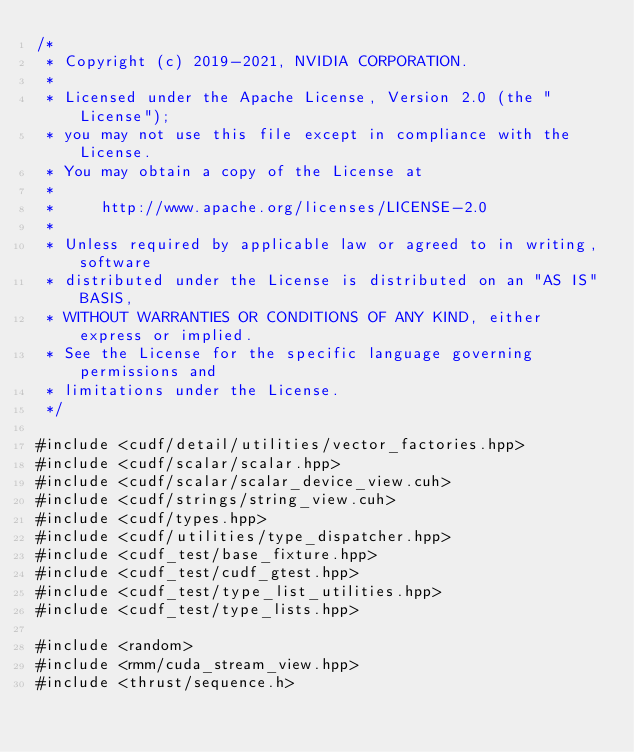<code> <loc_0><loc_0><loc_500><loc_500><_Cuda_>/*
 * Copyright (c) 2019-2021, NVIDIA CORPORATION.
 *
 * Licensed under the Apache License, Version 2.0 (the "License");
 * you may not use this file except in compliance with the License.
 * You may obtain a copy of the License at
 *
 *     http://www.apache.org/licenses/LICENSE-2.0
 *
 * Unless required by applicable law or agreed to in writing, software
 * distributed under the License is distributed on an "AS IS" BASIS,
 * WITHOUT WARRANTIES OR CONDITIONS OF ANY KIND, either express or implied.
 * See the License for the specific language governing permissions and
 * limitations under the License.
 */

#include <cudf/detail/utilities/vector_factories.hpp>
#include <cudf/scalar/scalar.hpp>
#include <cudf/scalar/scalar_device_view.cuh>
#include <cudf/strings/string_view.cuh>
#include <cudf/types.hpp>
#include <cudf/utilities/type_dispatcher.hpp>
#include <cudf_test/base_fixture.hpp>
#include <cudf_test/cudf_gtest.hpp>
#include <cudf_test/type_list_utilities.hpp>
#include <cudf_test/type_lists.hpp>

#include <random>
#include <rmm/cuda_stream_view.hpp>
#include <thrust/sequence.h>
</code> 